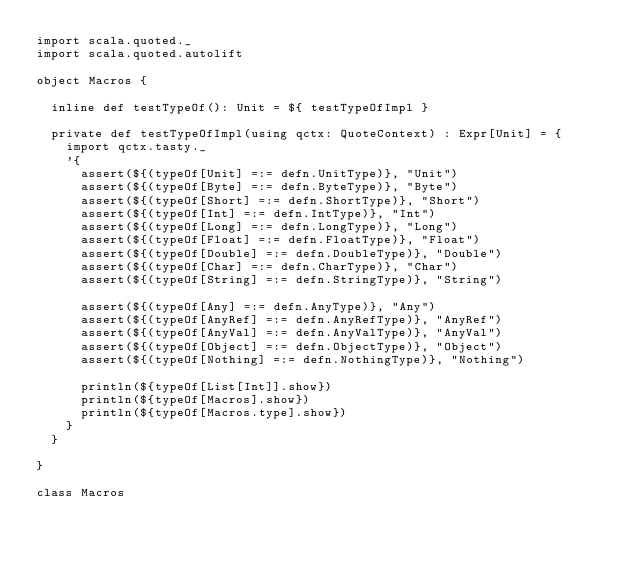Convert code to text. <code><loc_0><loc_0><loc_500><loc_500><_Scala_>import scala.quoted._
import scala.quoted.autolift

object Macros {

  inline def testTypeOf(): Unit = ${ testTypeOfImpl }

  private def testTypeOfImpl(using qctx: QuoteContext) : Expr[Unit] = {
    import qctx.tasty._
    '{
      assert(${(typeOf[Unit] =:= defn.UnitType)}, "Unit")
      assert(${(typeOf[Byte] =:= defn.ByteType)}, "Byte")
      assert(${(typeOf[Short] =:= defn.ShortType)}, "Short")
      assert(${(typeOf[Int] =:= defn.IntType)}, "Int")
      assert(${(typeOf[Long] =:= defn.LongType)}, "Long")
      assert(${(typeOf[Float] =:= defn.FloatType)}, "Float")
      assert(${(typeOf[Double] =:= defn.DoubleType)}, "Double")
      assert(${(typeOf[Char] =:= defn.CharType)}, "Char")
      assert(${(typeOf[String] =:= defn.StringType)}, "String")

      assert(${(typeOf[Any] =:= defn.AnyType)}, "Any")
      assert(${(typeOf[AnyRef] =:= defn.AnyRefType)}, "AnyRef")
      assert(${(typeOf[AnyVal] =:= defn.AnyValType)}, "AnyVal")
      assert(${(typeOf[Object] =:= defn.ObjectType)}, "Object")
      assert(${(typeOf[Nothing] =:= defn.NothingType)}, "Nothing")

      println(${typeOf[List[Int]].show})
      println(${typeOf[Macros].show})
      println(${typeOf[Macros.type].show})
    }
  }

}

class Macros
</code> 